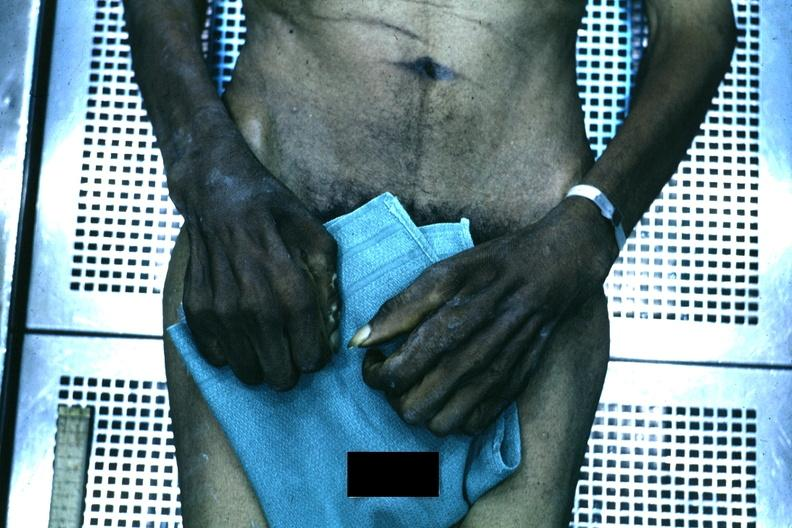what is present?
Answer the question using a single word or phrase. Hand 